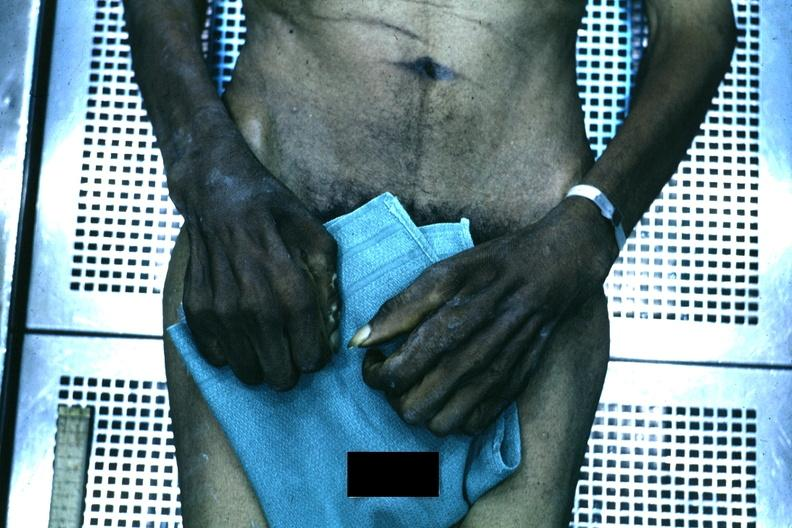what is present?
Answer the question using a single word or phrase. Hand 